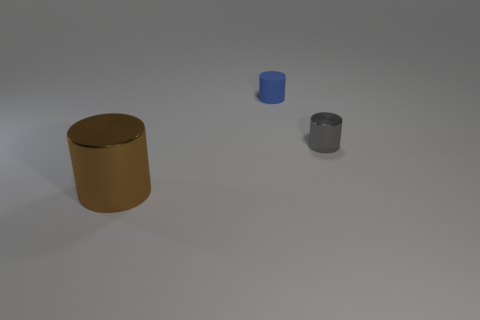Add 2 gray shiny cylinders. How many objects exist? 5 Add 2 gray cylinders. How many gray cylinders are left? 3 Add 1 small blue matte cubes. How many small blue matte cubes exist? 1 Subtract 1 brown cylinders. How many objects are left? 2 Subtract all small gray metallic objects. Subtract all metal things. How many objects are left? 0 